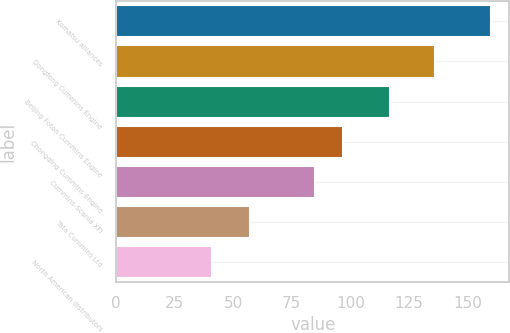Convert chart. <chart><loc_0><loc_0><loc_500><loc_500><bar_chart><fcel>Komatsu alliances<fcel>Dongfeng Cummins Engine<fcel>Beijing Foton Cummins Engine<fcel>Chongqing Cummins Engine<fcel>Cummins-Scania XPI<fcel>Tata Cummins Ltd<fcel>North American distributors<nl><fcel>160<fcel>136<fcel>117<fcel>96.9<fcel>85<fcel>57<fcel>41<nl></chart> 